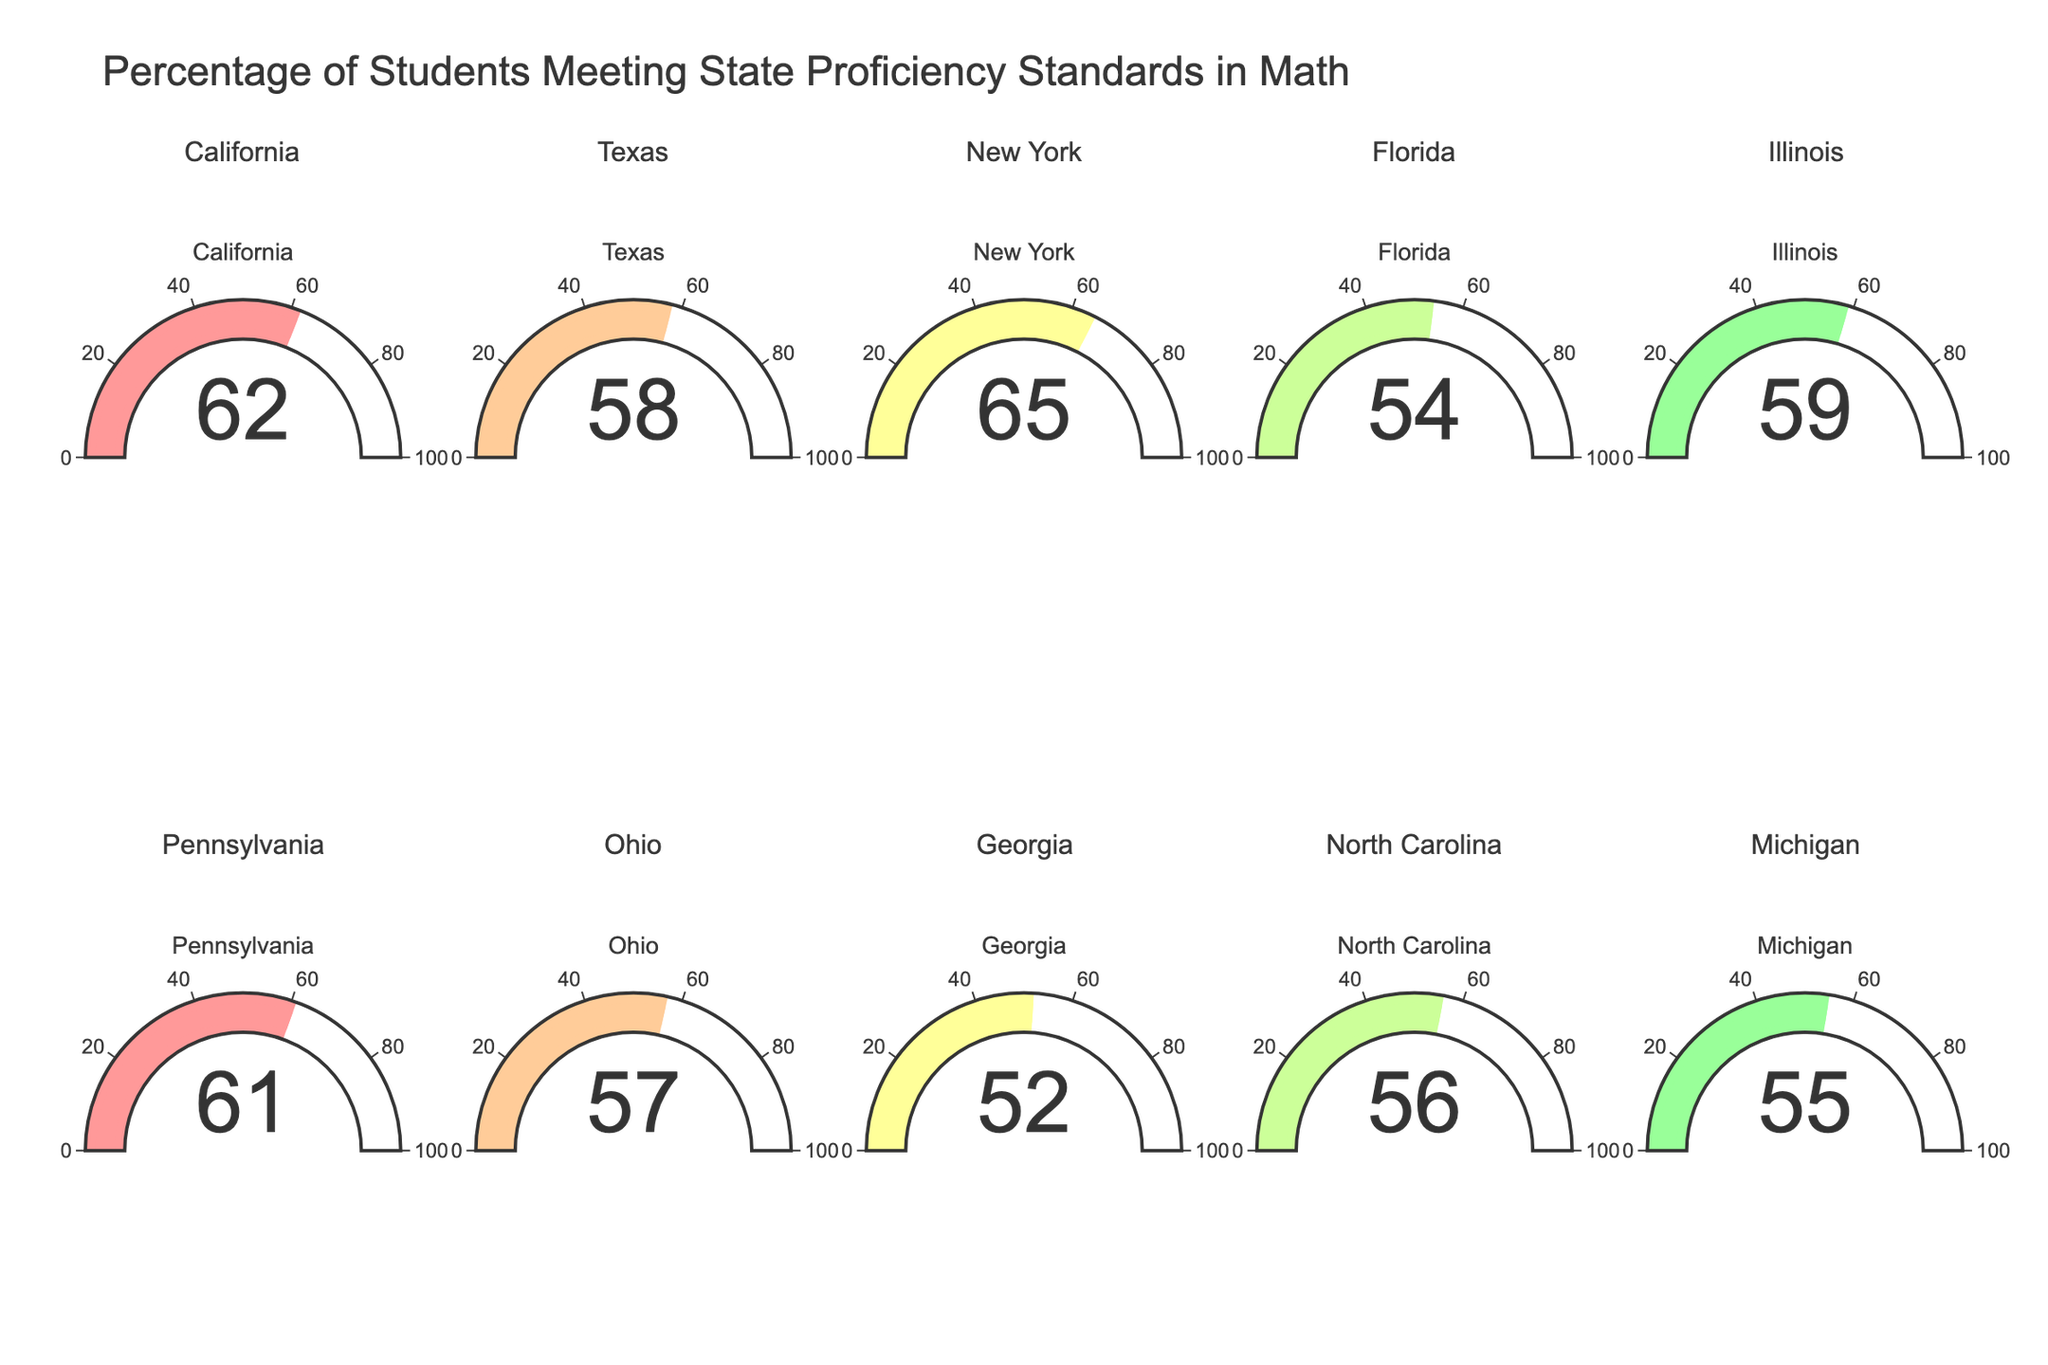What is the title of the figure? The title is presented at the top of the figure.
Answer: Percentage of Students Meeting State Proficiency Standards in Math Which state has the highest percentage of students meeting proficiency standards? By visually inspecting the gauges, New York has the highest value.
Answer: New York Which state has the lowest percentage of students meeting proficiency standards? By looking at the gauge values, Georgia has the lowest number.
Answer: Georgia What is the average percentage of students meeting proficiency standards across all states? Sum all given percentages: 62+58+65+54+59+61+57+52+56+55 = 579, then divide by the total number of states, 10: 579/10
Answer: 57.9 What is the range of percentages among all states? Subtract the smallest value (Georgia, 52) from the largest value (New York, 65): 65 - 52
Answer: 13 How many states have more than 60 percent of students meeting proficiency standards? Count the states with percentages greater than 60: California (62), New York (65), Pennsylvania (61)
Answer: 3 Which states have proficiency percentages above the average of 57.9 percent? Compare each state’s percentage to the average: California (62), New York (65), Illinois (59), Pennsylvania (61)
Answer: California, New York, Illinois, Pennsylvania Are there more states above or below the average proficiency percentage of 57.9 percent? Count the states above (4) and below (6) the average.
Answer: Below What is the median percentage of students meeting proficiency standards? Organize values in ascending order: 52, 54, 55, 56, 57, 58, 59, 61, 62, 65. The median is the middle value in the dataset (57 in this case).
Answer: 57 